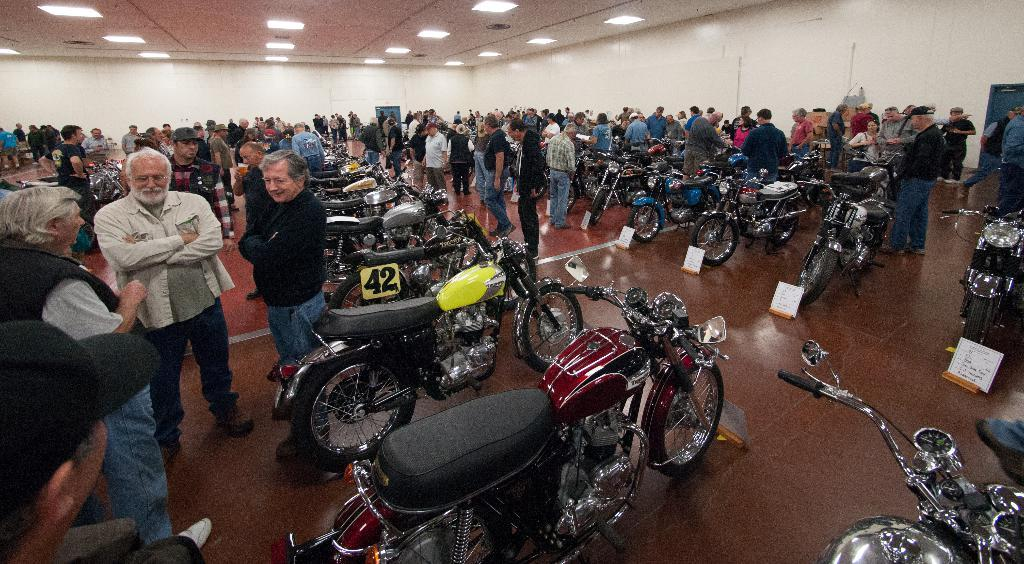Where was the image taken? The image was taken inside a room. What can be seen in the room? There are people standing in the room, and bikes are arranged in an order. What is visible at the top of the image? There are lights visible at the top of the image. Can you tell me how much milk is in the tub in the image? There is no tub or milk present in the image. What type of legal advice is the lawyer providing in the image? There is no lawyer present in the image. 